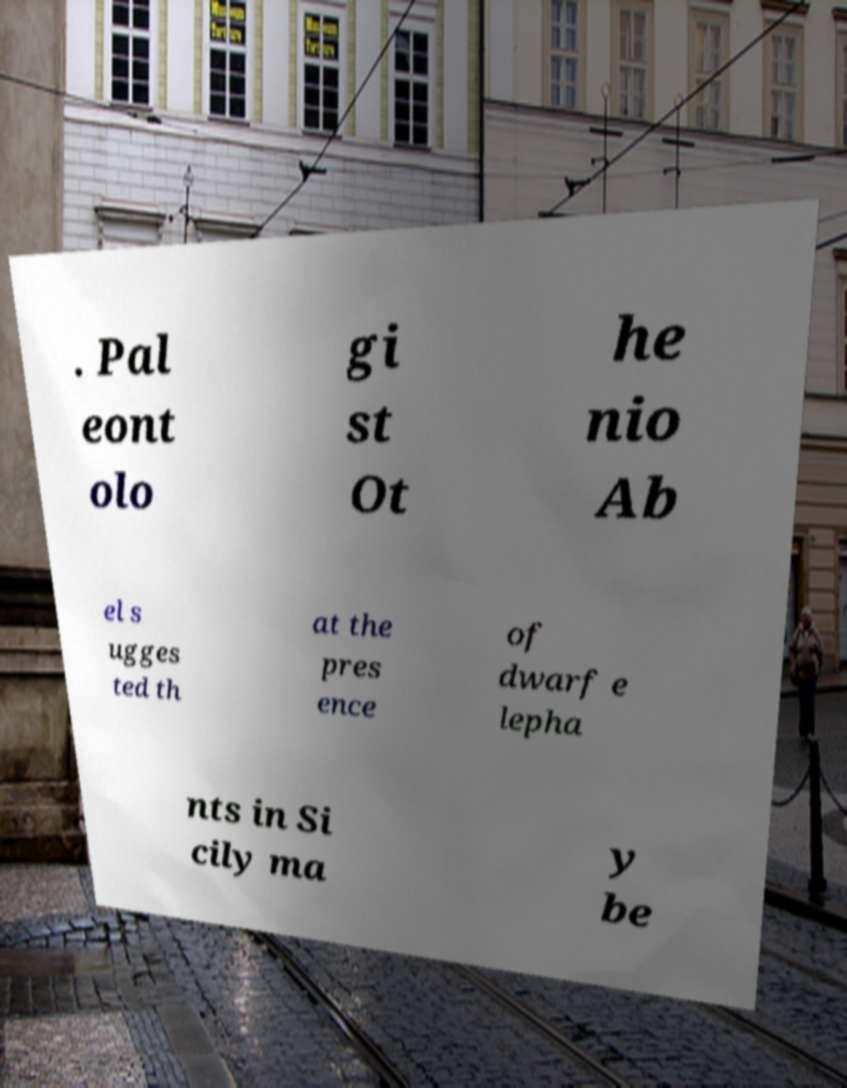Can you read and provide the text displayed in the image?This photo seems to have some interesting text. Can you extract and type it out for me? . Pal eont olo gi st Ot he nio Ab el s ugges ted th at the pres ence of dwarf e lepha nts in Si cily ma y be 